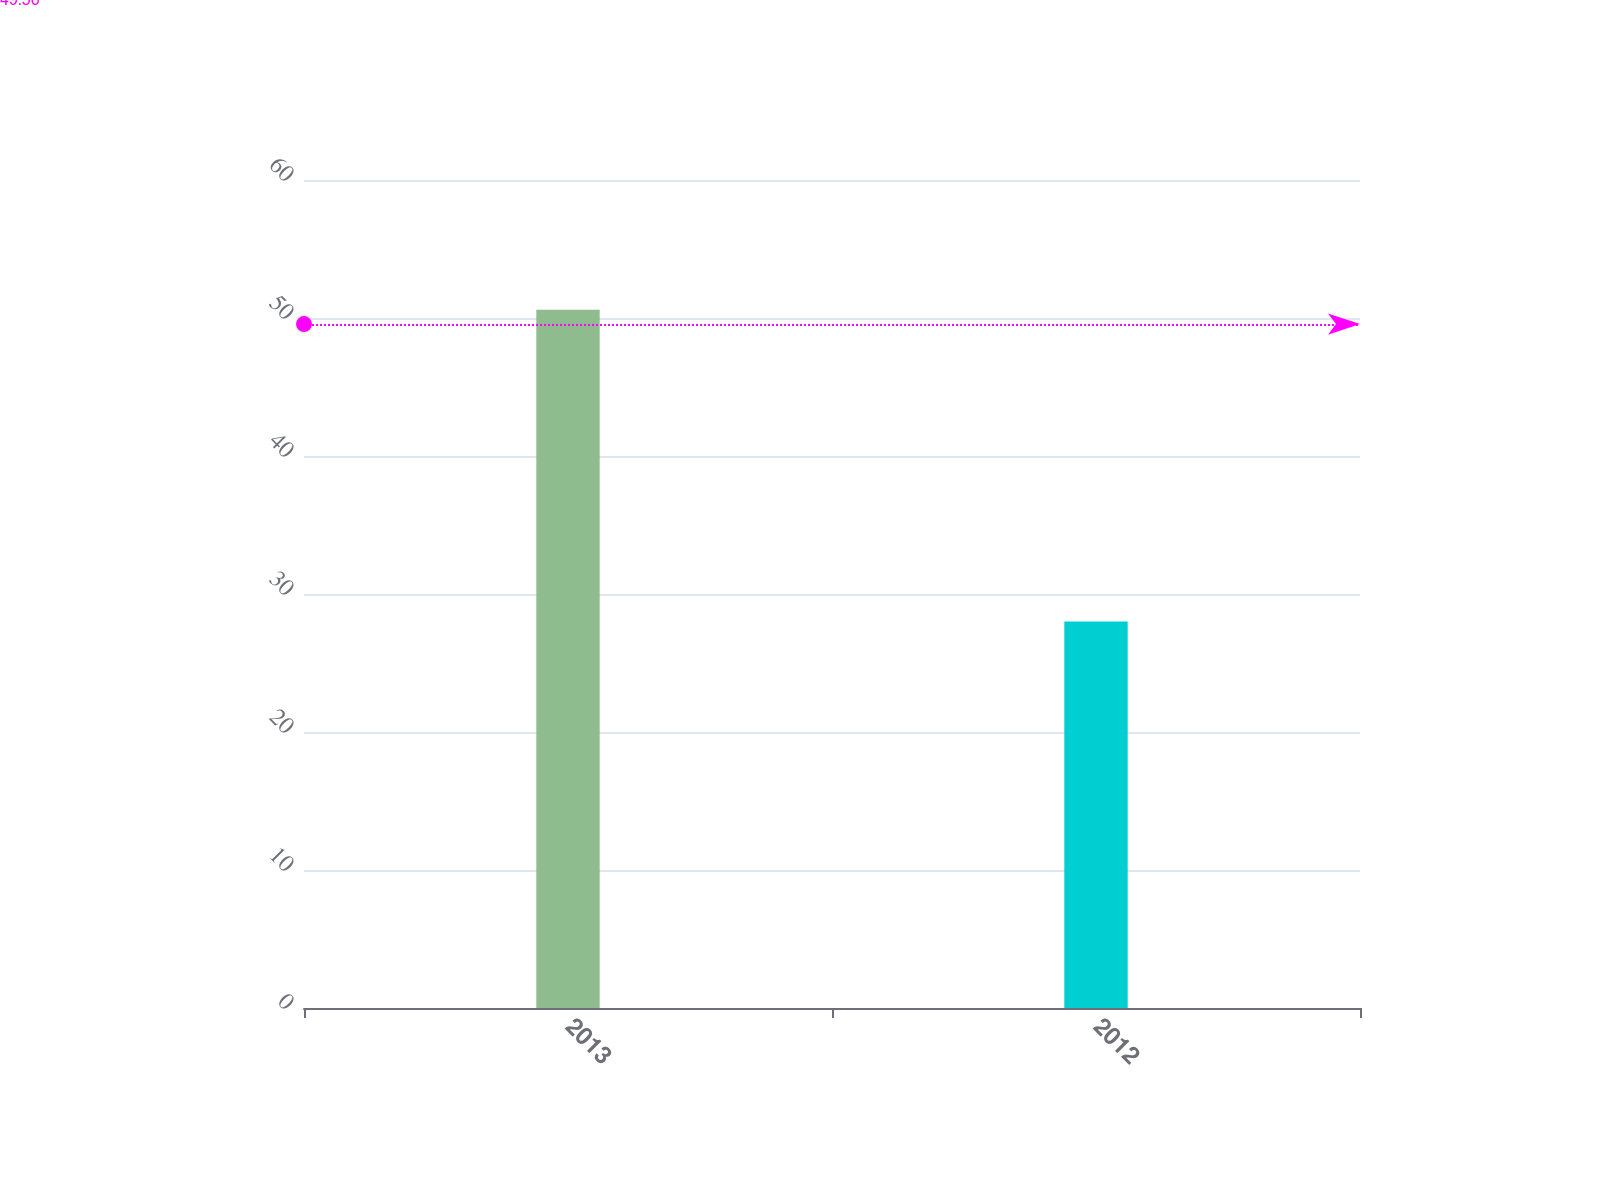Convert chart. <chart><loc_0><loc_0><loc_500><loc_500><bar_chart><fcel>2013<fcel>2012<nl><fcel>50.6<fcel>28.01<nl></chart> 